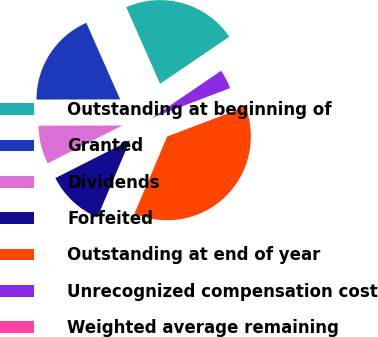Convert chart to OTSL. <chart><loc_0><loc_0><loc_500><loc_500><pie_chart><fcel>Outstanding at beginning of<fcel>Granted<fcel>Dividends<fcel>Forfeited<fcel>Outstanding at end of year<fcel>Unrecognized compensation cost<fcel>Weighted average remaining<nl><fcel>22.12%<fcel>18.41%<fcel>7.43%<fcel>11.15%<fcel>37.17%<fcel>3.72%<fcel>0.0%<nl></chart> 